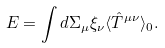<formula> <loc_0><loc_0><loc_500><loc_500>E = \int d \Sigma _ { \mu } \xi _ { \nu } \langle \hat { T } ^ { \mu \nu } \rangle _ { 0 } .</formula> 